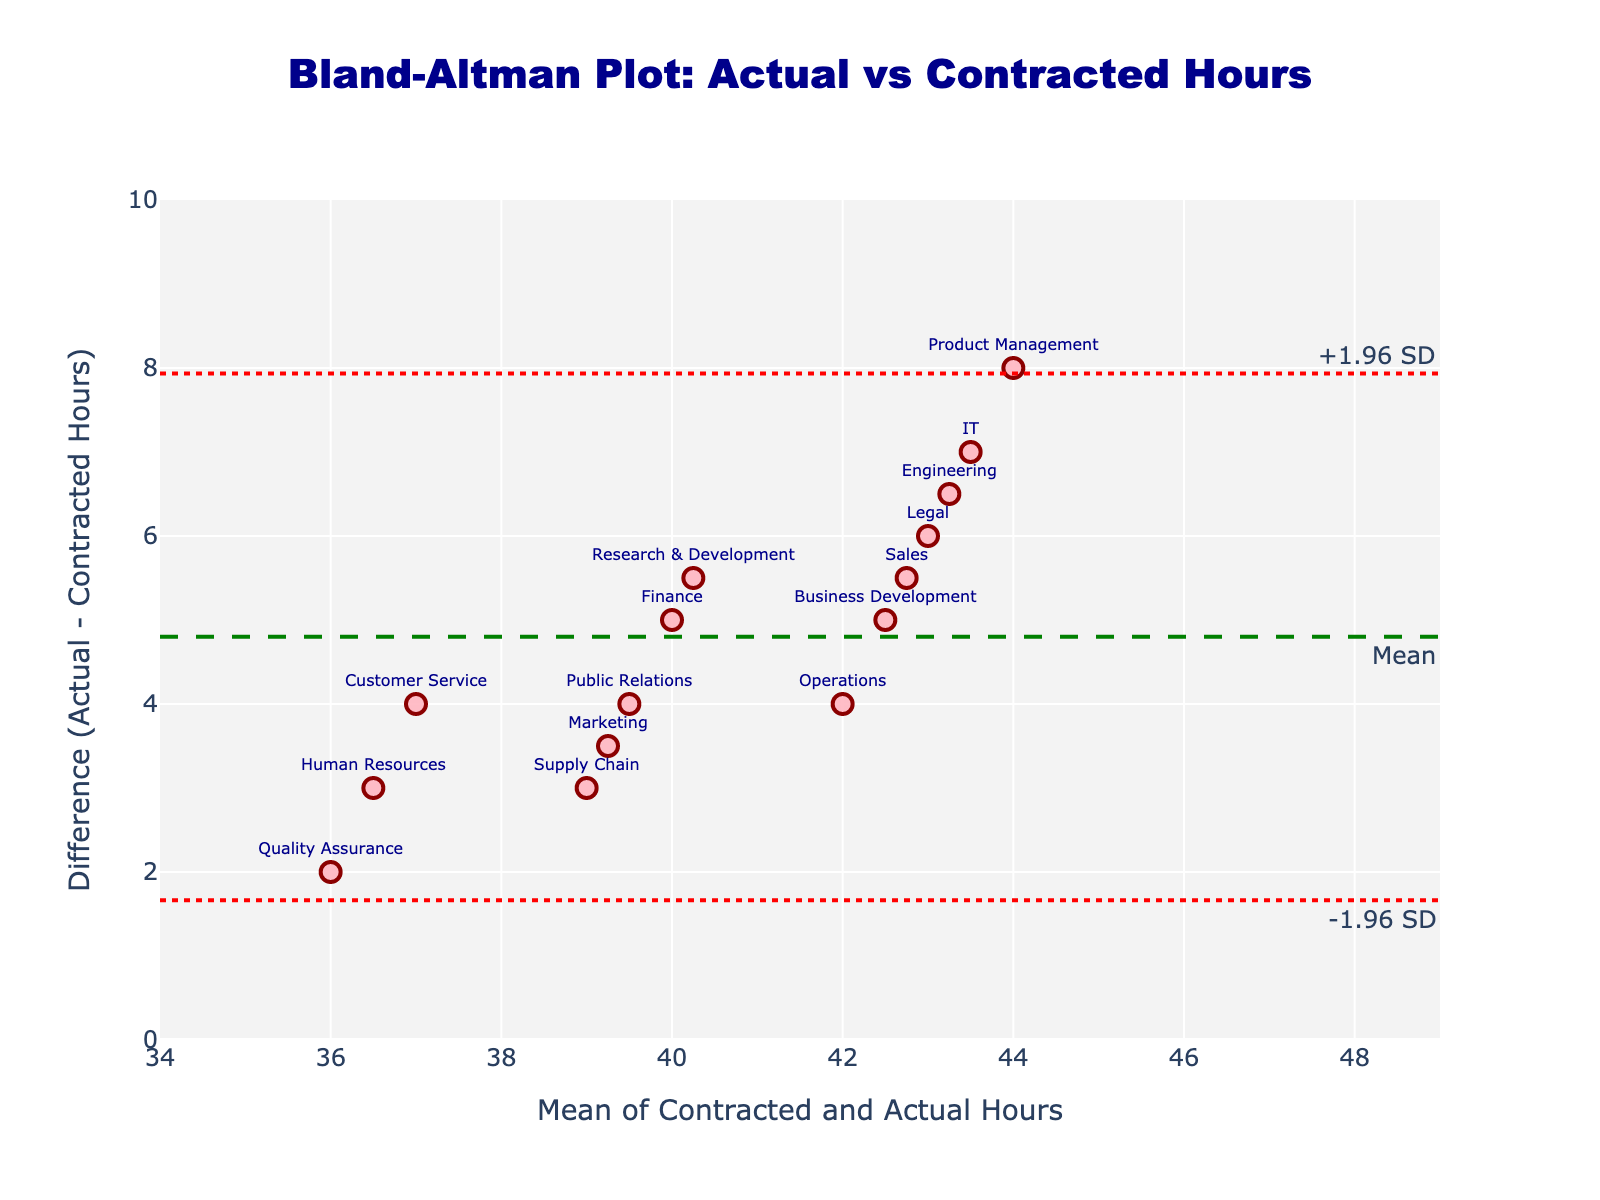What is the title of the plot? The title of the plot is usually displayed prominently at the top of the figure, and in this case, it is written clearly in a bold format.
Answer: Bland-Altman Plot: Actual vs Contracted Hours What is the y-axis titled? The y-axis title is a label typically positioned along the vertical axis of the plot, indicating what is being measured. In this plot, it is labeled to explain that it measures the difference between actual and contracted hours.
Answer: Difference (Actual - Contracted Hours) How many departments' data points are displayed on the plot? Each data point represents a department, and their count can be determined by visually inspecting the number of markers plotted. In this case, by counting the markers associated with department labels, we can find the total number of departments listed.
Answer: 15 What is the mean difference in hours between actual and contracted hours? The mean difference is typically indicated by a horizontal dashed line across the plot. The specific value can be obtained from the label on this line.
Answer: 5 What departments have the largest and smallest differences between actual and contracted hours? To answer this, identify the departments with the highest and lowest y-axis values, respectively, as these represent the largest and smallest differences. The text labels on the plot assist in pinpointing these departments.
Answer: Product Management (largest), Quality Assurance (smallest) What are the upper and lower limits of agreement? The upper and lower limits of agreement are marked by horizontal dotted lines. These values can usually be inferred from the position and annotations along these lines.
Answer: Upper: 6.98, Lower: 3.02 Which departments fall outside the limits of agreement? Identify data points (departments) that lie above the upper limit or below the lower limit by comparing their coordinates to the agreement lines. Labels on the plot will determine the specific departments.
Answer: None How does the difference between actual and contracted hours vary around the mean? Look at the spread of data points along the y-axis relative to the mean difference line to determine the variation. Notice departments above or below the mean line.
Answer: Most departments are spread relatively evenly around the mean difference of 5 hours Are there any departments where actual hours worked exactly match contracted hours? Points where the difference is zero would indicate exact matches. No such points lie on the y=0 line here.
Answer: No Which department has an average (mean) of contracted and actual hours closest to 41 hours? Observe the x-axis, which shows the mean of contracted and actual hours for each department, then match the nearest value to 41.
Answer: Business Development 